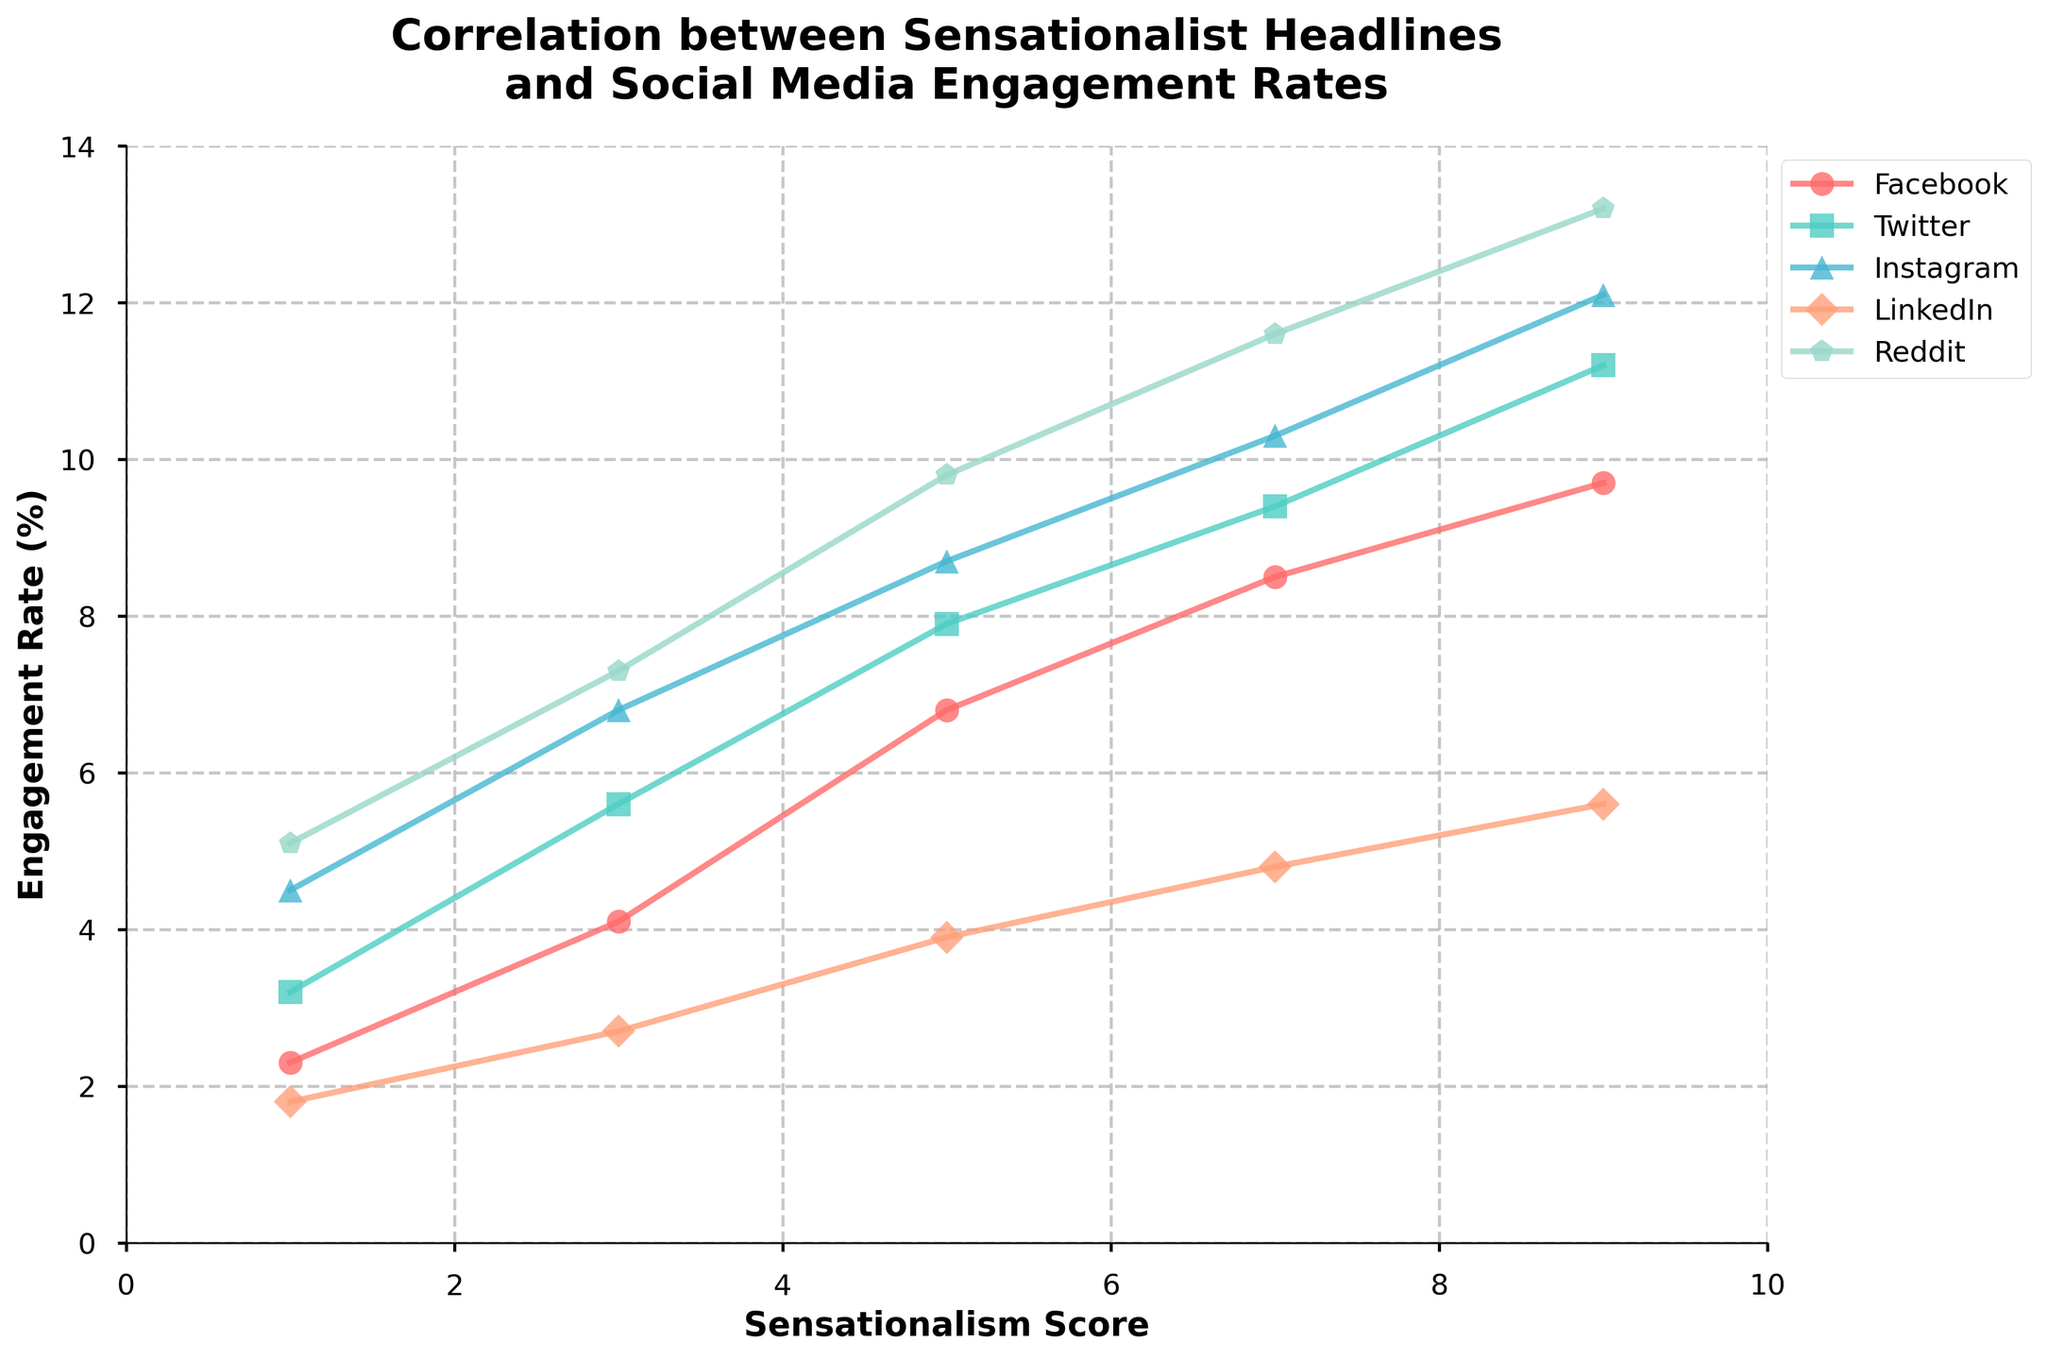What is the trend in engagement rate with an increase in sensationalism score on Instagram? As the sensationalism score increases from 1 to 9, the engagement rate on Instagram also rises consistently from 4.5 to 12.1. This shows a positive correlation between sensationalism score and engagement rate on Instagram.
Answer: Engagement rate increases with sensationalism score Which platform shows the highest engagement rate at a sensationalism score of 9? To answer this, we compare the engagement rates at a sensationalism score of 9 for each platform. The rates are Facebook (9.7%), Twitter (11.2%), Instagram (12.1%), LinkedIn (5.6%), and Reddit (13.2%). The highest engagement rate is on Reddit at 13.2%.
Answer: Reddit How does the engagement rate on LinkedIn compare to Facebook at each sensationalism score level? To compare the engagement rates, we check the values at each score level:
- 1: LinkedIn 1.8 vs. Facebook 2.3
- 3: LinkedIn 2.7 vs. Facebook 4.1
- 5: LinkedIn 3.9 vs. Facebook 6.8
- 7: LinkedIn 4.8 vs. Facebook 8.5
- 9: LinkedIn 5.6 vs. Facebook 9.7
At each level, Facebook consistently has a higher engagement rate than LinkedIn.
Answer: Facebook has a higher engagement rate at all levels Which platform has the most significant increase in engagement rate as the sensationalism score increases from 1 to 9? To determine the most significant increase, we calculate the difference in engagement rate from a score of 1 to 9 for each platform:
- Facebook: 9.7 - 2.3 = 7.4
- Twitter: 11.2 - 3.2 = 8
- Instagram: 12.1 - 4.5 = 7.6
- LinkedIn: 5.6 - 1.8 = 3.8
- Reddit: 13.2 - 5.1 = 8.1
Reddit has the largest increase, with a difference of 8.1.
Answer: Reddit What is the average engagement rate of Facebook across all sensationalism scores? To find the average engagement rate for Facebook, sum the engagement rates and divide by the number of scores:
(2.3 + 4.1 + 6.8 + 8.5 + 9.7) / 5 = 31.4 / 5 = 6.28
Answer: 6.28 At a sensationalism score of 5, which platform has the lowest engagement rate? Looking at the engagement rates for a score of 5, they are:
Facebook (6.8), Twitter (7.9), Instagram (8.7), LinkedIn (3.9), and Reddit (9.8). The lowest engagement rate at this score is on LinkedIn at 3.9.
Answer: LinkedIn 